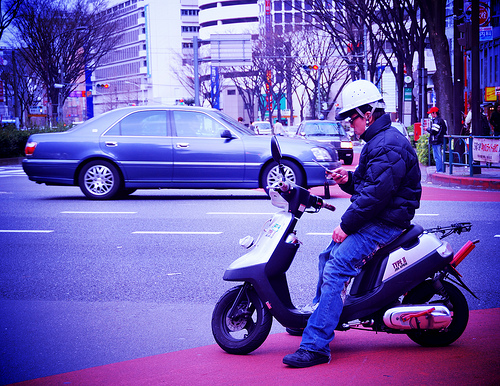Can you tell me about the setting where the scooter is located? The scooter is parked on the side of an urban street, which has clearly marked bike lanes. The presence of vehicles and city buildings in the background suggests this is a busy metropolitan area. 